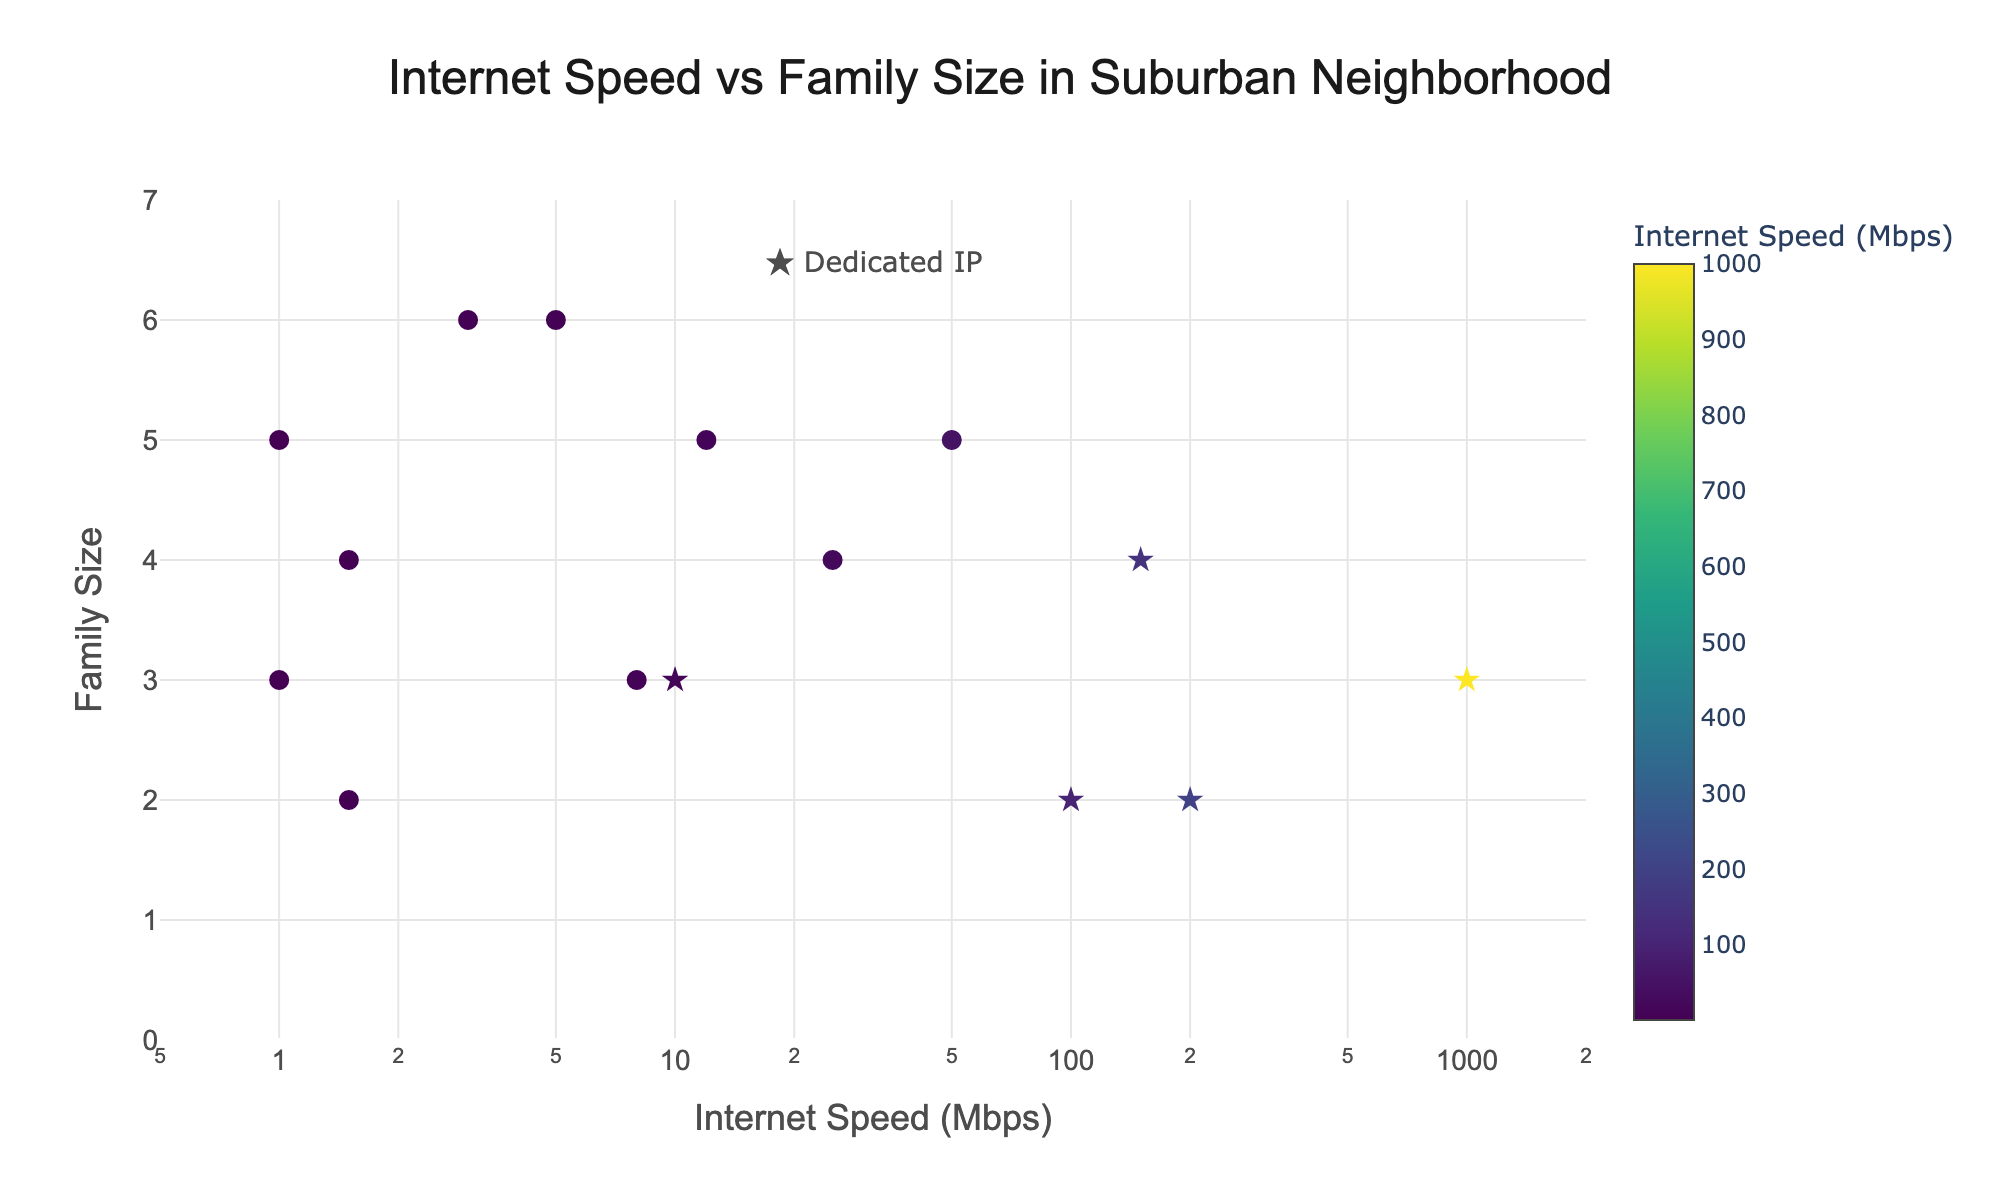How many homes have the highest internet speeds? To determine this, look at the points on the plot that have the highest internet speed on the x-axis. Since the x-axis is on a log scale, focus on the markers furthest to the right, which display 1000 Mbps. Identify the number of these markers.
Answer: 1 Which family size has the most varied range of internet speeds? Observe the y-axis representing family size and note the spread of points along the x-axis for each family size. For example, family sizes of 4 and 5 have data points scattered across a wide range of internet speeds from 1.5 Mbps to 150 Mbps (and even higher for family size 4). The family size with the broadest range will have points spread most widely along the x-axis.
Answer: 4 What is the average internet speed for families with a family size of 3? Identify all the points on the y-axis where family size equals 3. Read off their internet speeds from the x-axis: these are 10, 8, and 1000 Mbps. Calculate the average (10 + 8 + 1000) / 3.
Answer: 339.3 Mbps Which home has the lowest internet speed? Look at the plot and find the point nearest to the lower bound of the x-axis. The lowest speed visible on the x-axis is 1 Mbps. Identify the home associated with this point.
Answer: 201 Oak Street Are there more homes with dedicated IPs or without them? Check the markers on the plot where dedicated IPs are represented by stars and regular IPs by circles. Count the number of each symbol.
Answer: More homes without dedicated IPs What is the internet speed range for homes with a family size of 2? Locate the points on the y-axis where family size equals 2. Check the x-axis values for these points: 100, 1.5, and 200 Mbps. The range is from the minimum (1.5 Mbps) to the maximum (200 Mbps).
Answer: 1.5 to 200 Mbps For homes with dedicated IPs, what is the highest family size, and what is their internet speed? Identify the star-shaped markers indicating dedicated IPs and look for the one at the highest position on the y-axis. That point represents the highest family size with dedicated IPs. Check its corresponding x-axis value.
Answer: The highest family size is 4 with 150 Mbps What is the total number of homes displayed in the plot? Count all the data points represented on the plot, including those with both types of IP addresses.
Answer: 15 Which home has the highest family size with the lowest internet speed? Identify data points with the lowest internet speed (1 Mbps) on the x-axis. Among these, find the one with the highest family size on the y-axis.
Answer: 301 Pine Avenue 